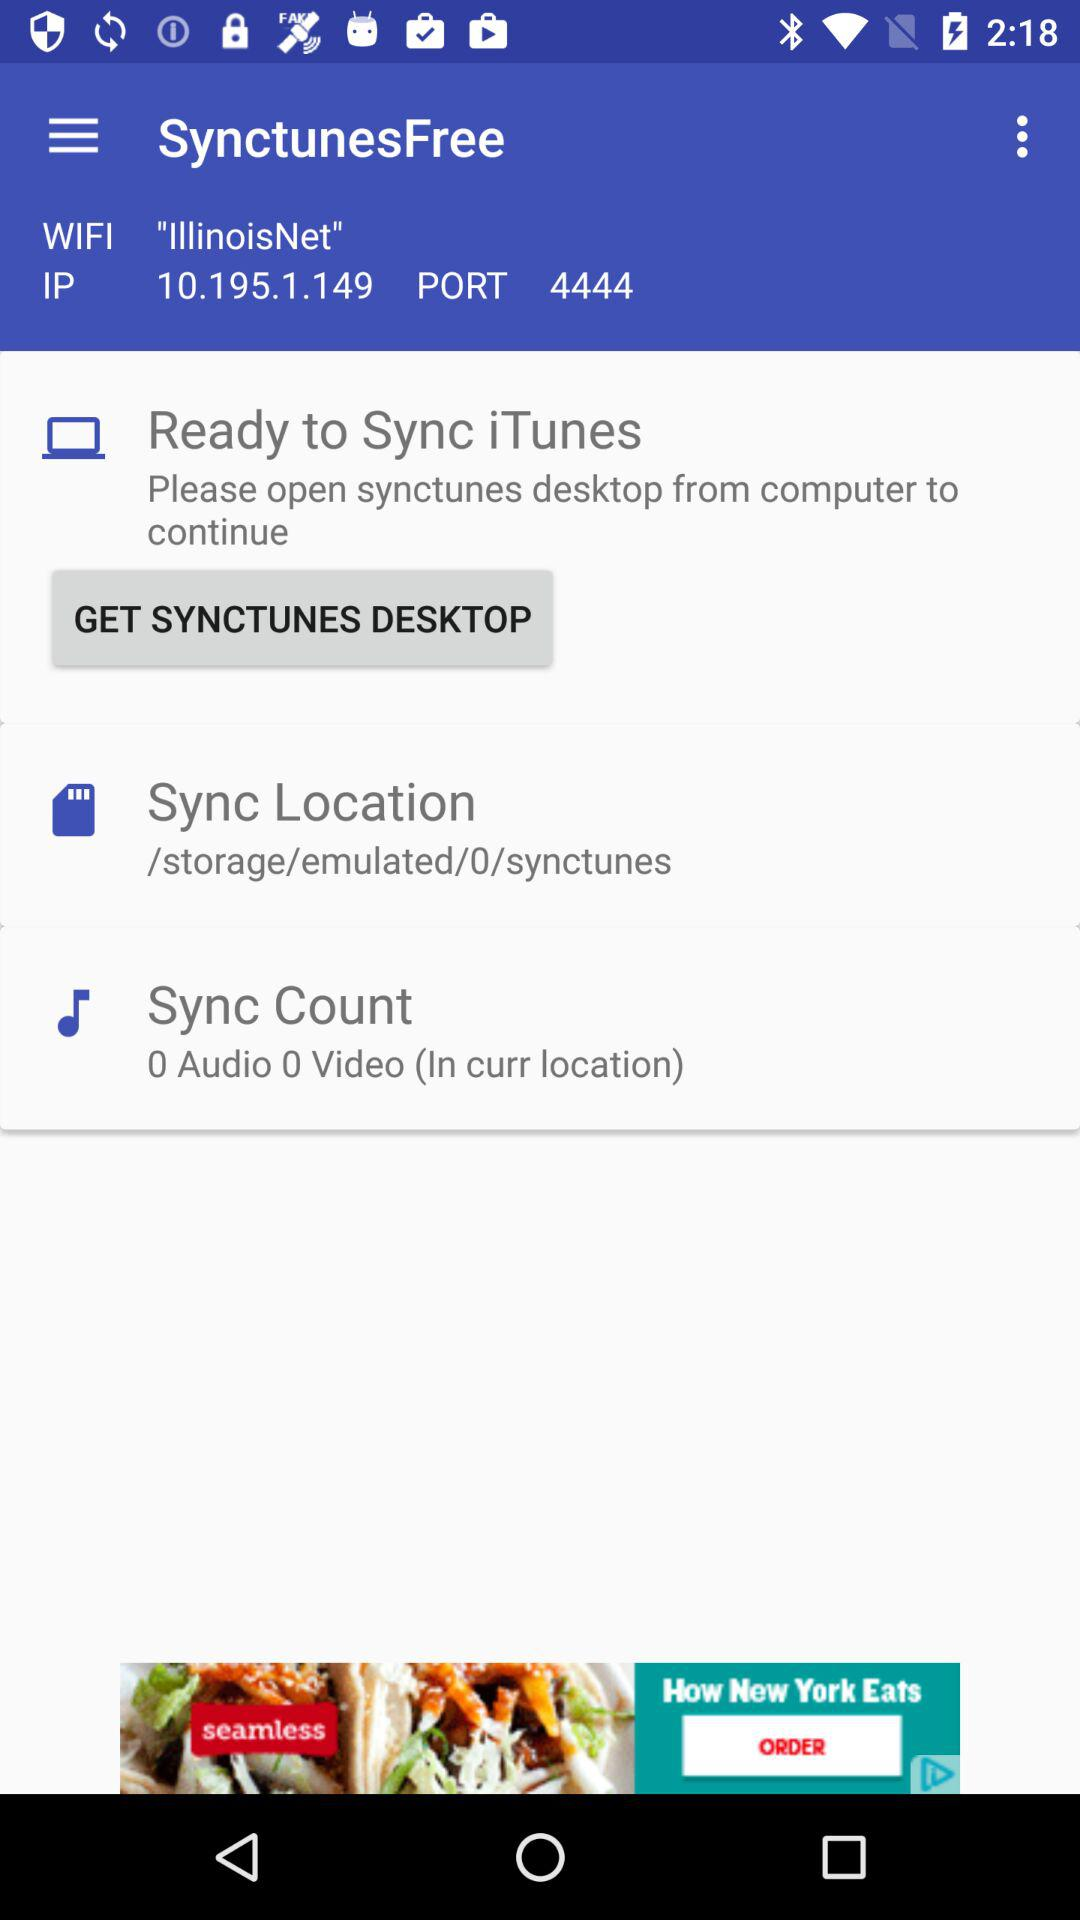How many videos and audios are in the "Sync Count"? There is 0 video and 0 audio in the "Sync Count". 